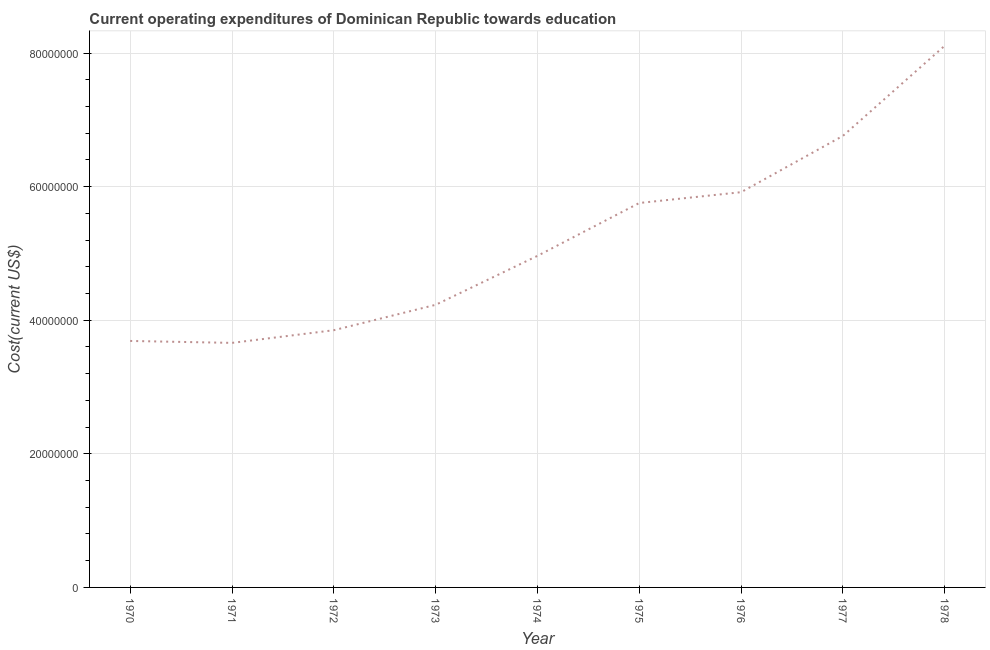What is the education expenditure in 1971?
Your answer should be compact. 3.66e+07. Across all years, what is the maximum education expenditure?
Your response must be concise. 8.11e+07. Across all years, what is the minimum education expenditure?
Keep it short and to the point. 3.66e+07. In which year was the education expenditure maximum?
Your answer should be compact. 1978. What is the sum of the education expenditure?
Ensure brevity in your answer.  4.69e+08. What is the difference between the education expenditure in 1975 and 1977?
Make the answer very short. -1.01e+07. What is the average education expenditure per year?
Your answer should be very brief. 5.22e+07. What is the median education expenditure?
Your answer should be very brief. 4.96e+07. What is the ratio of the education expenditure in 1972 to that in 1976?
Offer a very short reply. 0.65. Is the education expenditure in 1973 less than that in 1975?
Offer a very short reply. Yes. Is the difference between the education expenditure in 1973 and 1976 greater than the difference between any two years?
Provide a succinct answer. No. What is the difference between the highest and the second highest education expenditure?
Keep it short and to the point. 1.35e+07. What is the difference between the highest and the lowest education expenditure?
Make the answer very short. 4.45e+07. In how many years, is the education expenditure greater than the average education expenditure taken over all years?
Ensure brevity in your answer.  4. Does the education expenditure monotonically increase over the years?
Give a very brief answer. No. How many lines are there?
Offer a terse response. 1. What is the difference between two consecutive major ticks on the Y-axis?
Ensure brevity in your answer.  2.00e+07. Are the values on the major ticks of Y-axis written in scientific E-notation?
Ensure brevity in your answer.  No. Does the graph contain any zero values?
Make the answer very short. No. What is the title of the graph?
Your response must be concise. Current operating expenditures of Dominican Republic towards education. What is the label or title of the Y-axis?
Keep it short and to the point. Cost(current US$). What is the Cost(current US$) of 1970?
Make the answer very short. 3.69e+07. What is the Cost(current US$) in 1971?
Provide a short and direct response. 3.66e+07. What is the Cost(current US$) in 1972?
Make the answer very short. 3.85e+07. What is the Cost(current US$) in 1973?
Your answer should be very brief. 4.23e+07. What is the Cost(current US$) of 1974?
Offer a very short reply. 4.96e+07. What is the Cost(current US$) in 1975?
Your answer should be compact. 5.76e+07. What is the Cost(current US$) in 1976?
Make the answer very short. 5.92e+07. What is the Cost(current US$) of 1977?
Keep it short and to the point. 6.76e+07. What is the Cost(current US$) in 1978?
Ensure brevity in your answer.  8.11e+07. What is the difference between the Cost(current US$) in 1970 and 1971?
Your response must be concise. 2.90e+05. What is the difference between the Cost(current US$) in 1970 and 1972?
Offer a very short reply. -1.61e+06. What is the difference between the Cost(current US$) in 1970 and 1973?
Make the answer very short. -5.41e+06. What is the difference between the Cost(current US$) in 1970 and 1974?
Your answer should be compact. -1.27e+07. What is the difference between the Cost(current US$) in 1970 and 1975?
Make the answer very short. -2.07e+07. What is the difference between the Cost(current US$) in 1970 and 1976?
Provide a short and direct response. -2.23e+07. What is the difference between the Cost(current US$) in 1970 and 1977?
Provide a succinct answer. -3.07e+07. What is the difference between the Cost(current US$) in 1970 and 1978?
Make the answer very short. -4.42e+07. What is the difference between the Cost(current US$) in 1971 and 1972?
Your answer should be compact. -1.90e+06. What is the difference between the Cost(current US$) in 1971 and 1973?
Make the answer very short. -5.70e+06. What is the difference between the Cost(current US$) in 1971 and 1974?
Your response must be concise. -1.30e+07. What is the difference between the Cost(current US$) in 1971 and 1975?
Make the answer very short. -2.09e+07. What is the difference between the Cost(current US$) in 1971 and 1976?
Provide a succinct answer. -2.26e+07. What is the difference between the Cost(current US$) in 1971 and 1977?
Your answer should be compact. -3.10e+07. What is the difference between the Cost(current US$) in 1971 and 1978?
Make the answer very short. -4.45e+07. What is the difference between the Cost(current US$) in 1972 and 1973?
Keep it short and to the point. -3.80e+06. What is the difference between the Cost(current US$) in 1972 and 1974?
Your answer should be compact. -1.11e+07. What is the difference between the Cost(current US$) in 1972 and 1975?
Offer a terse response. -1.90e+07. What is the difference between the Cost(current US$) in 1972 and 1976?
Offer a terse response. -2.07e+07. What is the difference between the Cost(current US$) in 1972 and 1977?
Keep it short and to the point. -2.91e+07. What is the difference between the Cost(current US$) in 1972 and 1978?
Ensure brevity in your answer.  -4.26e+07. What is the difference between the Cost(current US$) in 1973 and 1974?
Offer a very short reply. -7.33e+06. What is the difference between the Cost(current US$) in 1973 and 1975?
Your answer should be very brief. -1.52e+07. What is the difference between the Cost(current US$) in 1973 and 1976?
Provide a short and direct response. -1.69e+07. What is the difference between the Cost(current US$) in 1973 and 1977?
Ensure brevity in your answer.  -2.53e+07. What is the difference between the Cost(current US$) in 1973 and 1978?
Your response must be concise. -3.88e+07. What is the difference between the Cost(current US$) in 1974 and 1975?
Provide a short and direct response. -7.91e+06. What is the difference between the Cost(current US$) in 1974 and 1976?
Provide a succinct answer. -9.53e+06. What is the difference between the Cost(current US$) in 1974 and 1977?
Make the answer very short. -1.80e+07. What is the difference between the Cost(current US$) in 1974 and 1978?
Ensure brevity in your answer.  -3.15e+07. What is the difference between the Cost(current US$) in 1975 and 1976?
Provide a succinct answer. -1.62e+06. What is the difference between the Cost(current US$) in 1975 and 1977?
Give a very brief answer. -1.01e+07. What is the difference between the Cost(current US$) in 1975 and 1978?
Keep it short and to the point. -2.36e+07. What is the difference between the Cost(current US$) in 1976 and 1977?
Offer a very short reply. -8.43e+06. What is the difference between the Cost(current US$) in 1976 and 1978?
Provide a short and direct response. -2.19e+07. What is the difference between the Cost(current US$) in 1977 and 1978?
Give a very brief answer. -1.35e+07. What is the ratio of the Cost(current US$) in 1970 to that in 1971?
Provide a short and direct response. 1.01. What is the ratio of the Cost(current US$) in 1970 to that in 1972?
Your answer should be very brief. 0.96. What is the ratio of the Cost(current US$) in 1970 to that in 1973?
Offer a very short reply. 0.87. What is the ratio of the Cost(current US$) in 1970 to that in 1974?
Your response must be concise. 0.74. What is the ratio of the Cost(current US$) in 1970 to that in 1975?
Offer a terse response. 0.64. What is the ratio of the Cost(current US$) in 1970 to that in 1976?
Give a very brief answer. 0.62. What is the ratio of the Cost(current US$) in 1970 to that in 1977?
Provide a succinct answer. 0.55. What is the ratio of the Cost(current US$) in 1970 to that in 1978?
Offer a very short reply. 0.46. What is the ratio of the Cost(current US$) in 1971 to that in 1972?
Ensure brevity in your answer.  0.95. What is the ratio of the Cost(current US$) in 1971 to that in 1973?
Your answer should be compact. 0.86. What is the ratio of the Cost(current US$) in 1971 to that in 1974?
Ensure brevity in your answer.  0.74. What is the ratio of the Cost(current US$) in 1971 to that in 1975?
Your answer should be compact. 0.64. What is the ratio of the Cost(current US$) in 1971 to that in 1976?
Provide a short and direct response. 0.62. What is the ratio of the Cost(current US$) in 1971 to that in 1977?
Your answer should be very brief. 0.54. What is the ratio of the Cost(current US$) in 1971 to that in 1978?
Give a very brief answer. 0.45. What is the ratio of the Cost(current US$) in 1972 to that in 1973?
Provide a short and direct response. 0.91. What is the ratio of the Cost(current US$) in 1972 to that in 1974?
Your answer should be very brief. 0.78. What is the ratio of the Cost(current US$) in 1972 to that in 1975?
Your answer should be compact. 0.67. What is the ratio of the Cost(current US$) in 1972 to that in 1976?
Offer a very short reply. 0.65. What is the ratio of the Cost(current US$) in 1972 to that in 1977?
Your response must be concise. 0.57. What is the ratio of the Cost(current US$) in 1972 to that in 1978?
Make the answer very short. 0.47. What is the ratio of the Cost(current US$) in 1973 to that in 1974?
Offer a very short reply. 0.85. What is the ratio of the Cost(current US$) in 1973 to that in 1975?
Your answer should be very brief. 0.73. What is the ratio of the Cost(current US$) in 1973 to that in 1976?
Make the answer very short. 0.71. What is the ratio of the Cost(current US$) in 1973 to that in 1977?
Provide a succinct answer. 0.63. What is the ratio of the Cost(current US$) in 1973 to that in 1978?
Ensure brevity in your answer.  0.52. What is the ratio of the Cost(current US$) in 1974 to that in 1975?
Give a very brief answer. 0.86. What is the ratio of the Cost(current US$) in 1974 to that in 1976?
Make the answer very short. 0.84. What is the ratio of the Cost(current US$) in 1974 to that in 1977?
Your response must be concise. 0.73. What is the ratio of the Cost(current US$) in 1974 to that in 1978?
Ensure brevity in your answer.  0.61. What is the ratio of the Cost(current US$) in 1975 to that in 1977?
Your response must be concise. 0.85. What is the ratio of the Cost(current US$) in 1975 to that in 1978?
Make the answer very short. 0.71. What is the ratio of the Cost(current US$) in 1976 to that in 1978?
Ensure brevity in your answer.  0.73. What is the ratio of the Cost(current US$) in 1977 to that in 1978?
Keep it short and to the point. 0.83. 